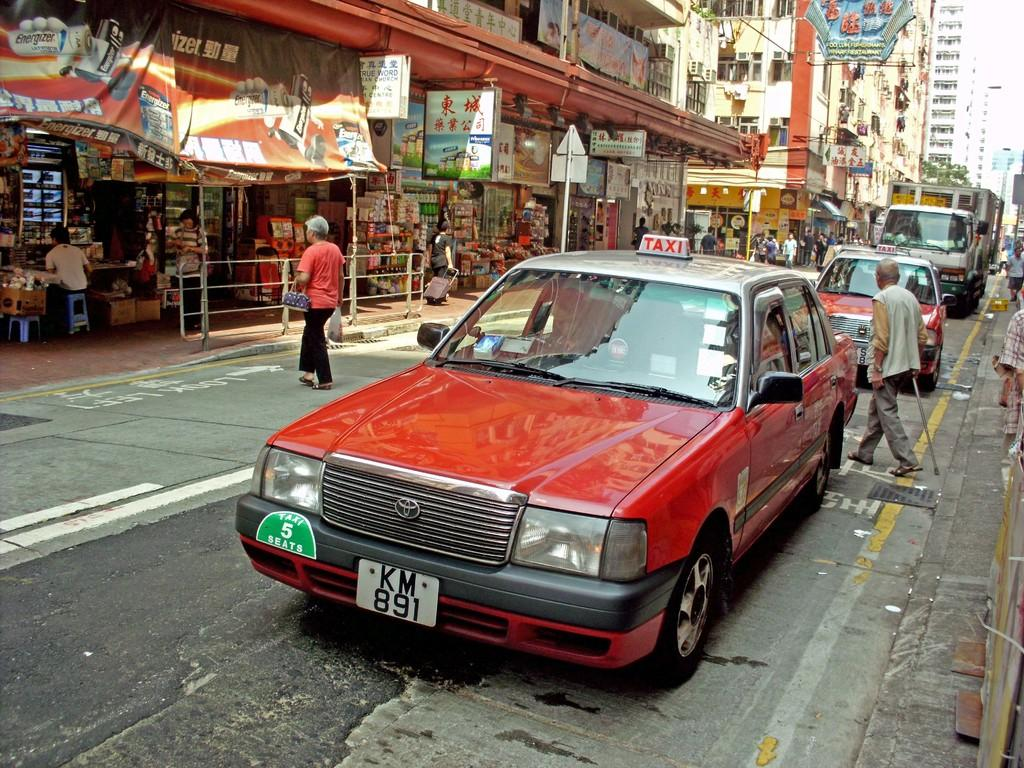<image>
Present a compact description of the photo's key features. Busy city street with a red vehicle and a rectangular sign on top with TAXI on it. 